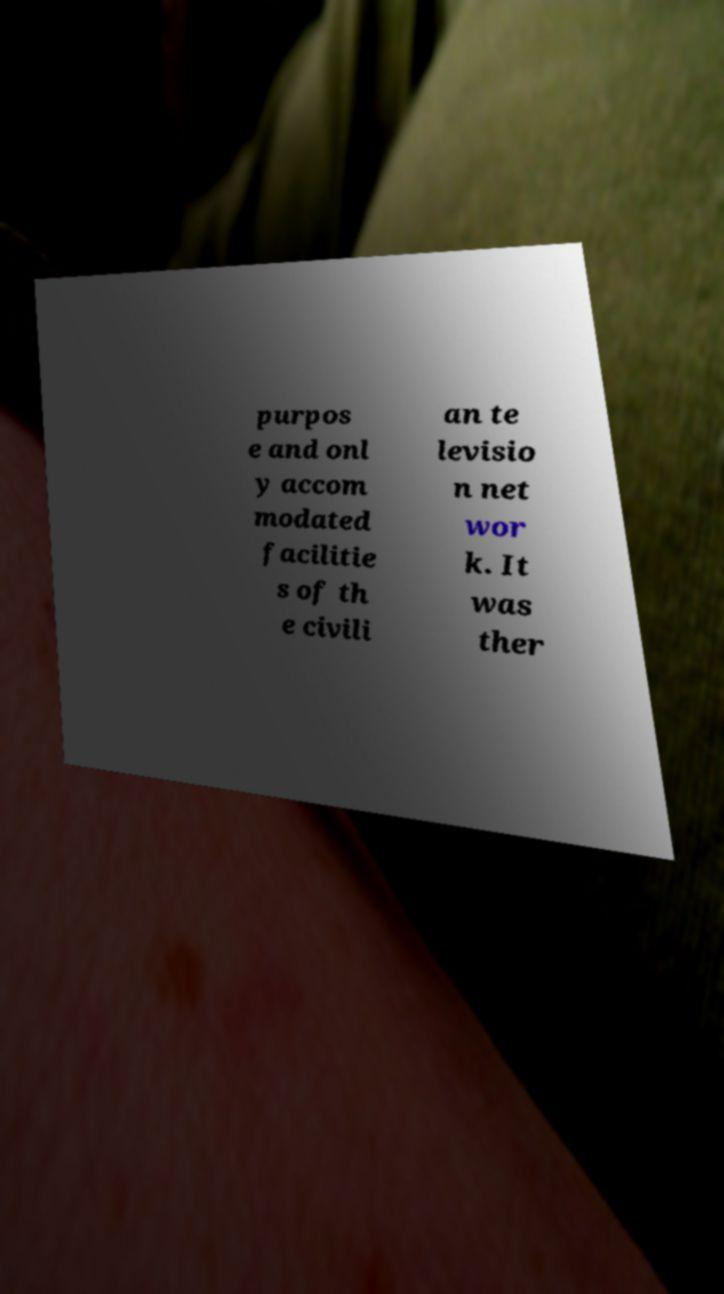What messages or text are displayed in this image? I need them in a readable, typed format. purpos e and onl y accom modated facilitie s of th e civili an te levisio n net wor k. It was ther 